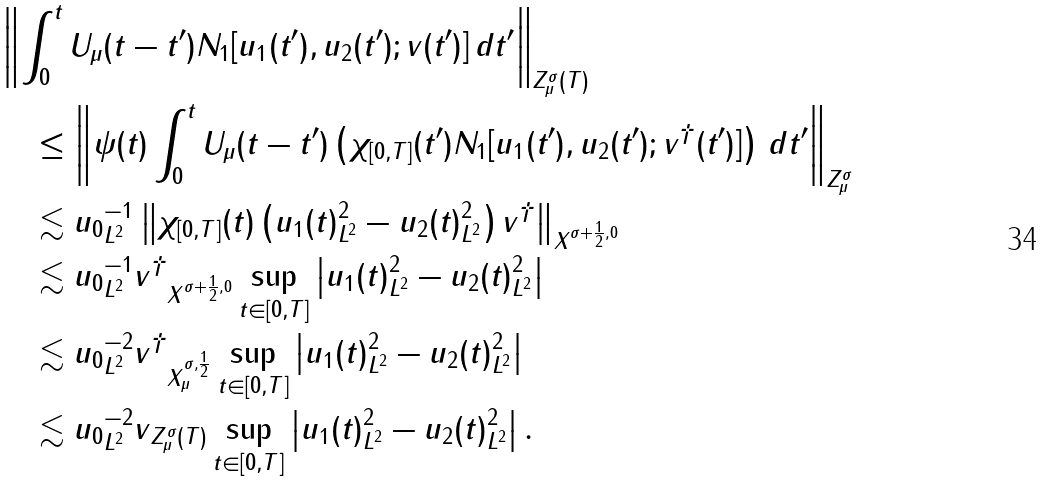<formula> <loc_0><loc_0><loc_500><loc_500>& \left \| \int _ { 0 } ^ { t } U _ { \mu } ( t - t ^ { \prime } ) N _ { 1 } [ u _ { 1 } ( t ^ { \prime } ) , u _ { 2 } ( t ^ { \prime } ) ; v ( t ^ { \prime } ) ] \, d t ^ { \prime } \right \| _ { Z ^ { \sigma } _ { \mu } ( T ) } \\ & \quad \leq \left \| \psi ( t ) \int _ { 0 } ^ { t } U _ { \mu } ( t - t ^ { \prime } ) \left ( \chi _ { [ 0 , T ] } ( t ^ { \prime } ) N _ { 1 } [ u _ { 1 } ( t ^ { \prime } ) , u _ { 2 } ( t ^ { \prime } ) ; v ^ { \dagger } ( t ^ { \prime } ) ] \right ) \, d t ^ { \prime } \right \| _ { Z ^ { \sigma } _ { \mu } } \\ & \quad \lesssim \| u _ { 0 } \| _ { L ^ { 2 } } ^ { - 1 } \left \| \chi _ { [ 0 , T ] } ( t ) \left ( \| u _ { 1 } ( t ) \| _ { L ^ { 2 } } ^ { 2 } - \| u _ { 2 } ( t ) \| _ { L ^ { 2 } } ^ { 2 } \right ) v ^ { \dagger } \right \| _ { X ^ { \sigma + \frac { 1 } { 2 } , 0 } } \\ & \quad \lesssim \| u _ { 0 } \| _ { L ^ { 2 } } ^ { - 1 } \| v ^ { \dagger } \| _ { X ^ { \sigma + \frac { 1 } { 2 } , 0 } } \sup _ { t \in [ 0 , T ] } \left | \| u _ { 1 } ( t ) \| _ { L ^ { 2 } } ^ { 2 } - \| u _ { 2 } ( t ) \| _ { L ^ { 2 } } ^ { 2 } \right | \\ & \quad \lesssim \| u _ { 0 } \| _ { L ^ { 2 } } ^ { - 2 } \| v ^ { \dagger } \| _ { X ^ { \sigma , \frac { 1 } { 2 } } _ { \mu } } \sup _ { t \in [ 0 , T ] } \left | \| u _ { 1 } ( t ) \| _ { L ^ { 2 } } ^ { 2 } - \| u _ { 2 } ( t ) \| _ { L ^ { 2 } } ^ { 2 } \right | \\ & \quad \lesssim \| u _ { 0 } \| _ { L ^ { 2 } } ^ { - 2 } \| v \| _ { Z ^ { \sigma } _ { \mu } ( T ) } \sup _ { t \in [ 0 , T ] } \left | \| u _ { 1 } ( t ) \| _ { L ^ { 2 } } ^ { 2 } - \| u _ { 2 } ( t ) \| _ { L ^ { 2 } } ^ { 2 } \right | .</formula> 